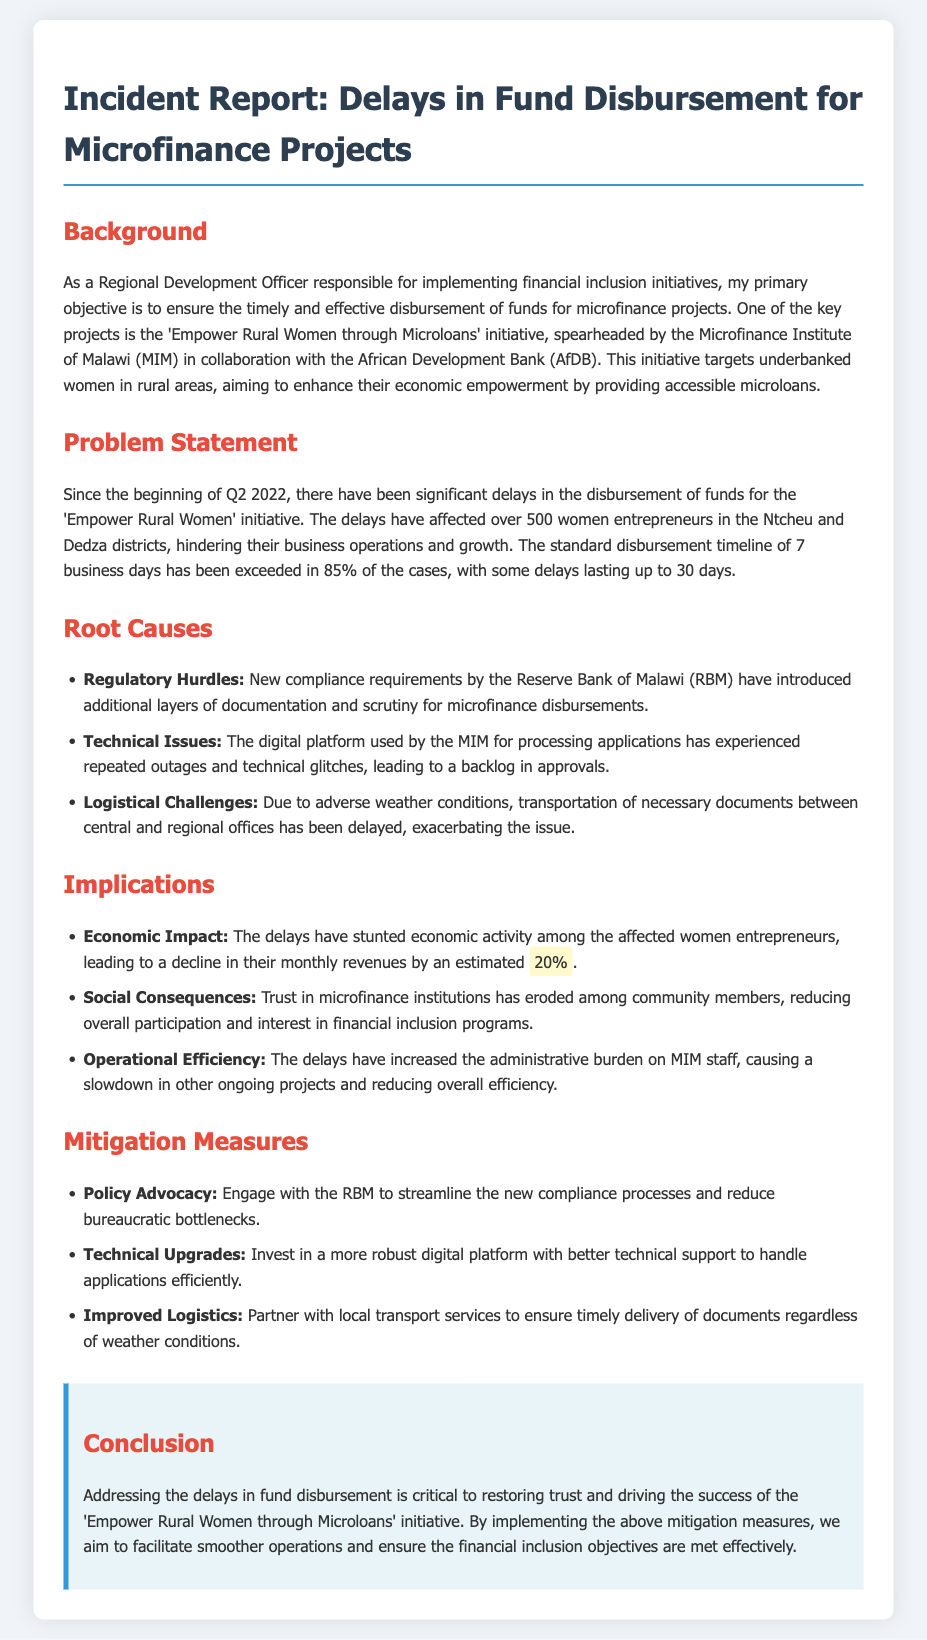What is the primary objective of the Regional Development Officer? The primary objective is to ensure the timely and effective disbursement of funds for microfinance projects.
Answer: timely and effective disbursement How many women entrepreneurs are affected by the delays? The report states that over 500 women entrepreneurs are affected by the delays.
Answer: over 500 What percentage of cases have exceeded the standard disbursement timeline? The document mentions that 85% of the cases have exceeded the standard disbursement timeline.
Answer: 85% What is one root cause of the delays? One root cause identified is new compliance requirements by the Reserve Bank of Malawi.
Answer: Regulatory Hurdles By what estimated percentage has the monthly revenue declined? The document states that there has been a decline in their monthly revenues by an estimated 20%.
Answer: 20% What are the two districts mentioned affected by the delays? The affected districts mentioned in the report are Ntcheu and Dedza.
Answer: Ntcheu and Dedza What measure is proposed to improve logistical challenges? The report suggests partnering with local transport services to ensure timely delivery of documents.
Answer: Partner with local transport services What initiative is being affected by the delays? The initiative named is 'Empower Rural Women through Microloans'.
Answer: Empower Rural Women through Microloans What is the main consequence of eroded trust in microfinance? The consequence mentioned is a reduction in overall participation and interest in financial inclusion programs.
Answer: Reduction in overall participation 